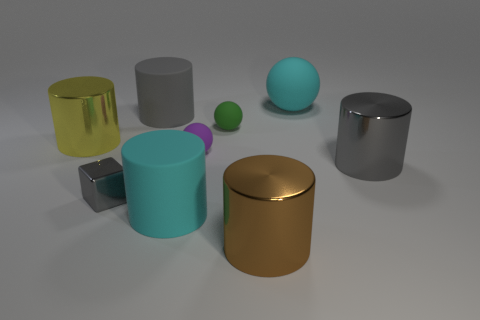Subtract all cyan spheres. How many spheres are left? 2 Subtract all big cyan balls. How many balls are left? 2 Subtract all cylinders. How many objects are left? 4 Subtract 1 balls. How many balls are left? 2 Subtract all yellow cylinders. Subtract all green spheres. How many cylinders are left? 4 Subtract all purple cubes. How many yellow cylinders are left? 1 Subtract all tiny spheres. Subtract all yellow cylinders. How many objects are left? 6 Add 1 purple matte balls. How many purple matte balls are left? 2 Add 3 large cylinders. How many large cylinders exist? 8 Add 1 large brown matte balls. How many objects exist? 10 